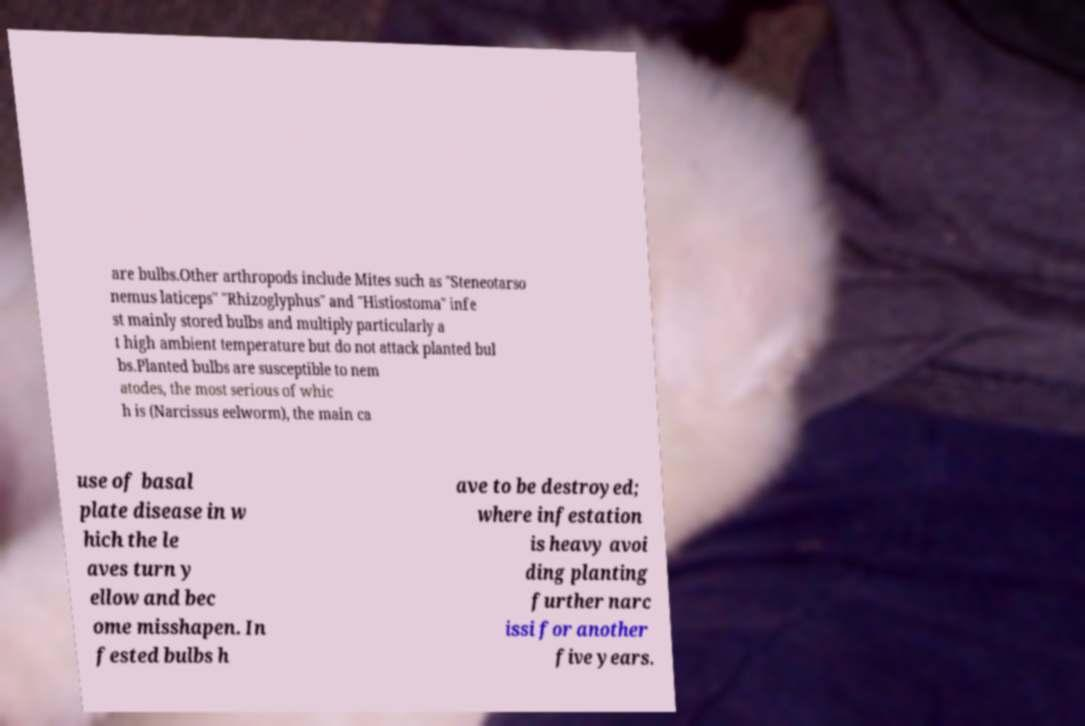Can you read and provide the text displayed in the image?This photo seems to have some interesting text. Can you extract and type it out for me? are bulbs.Other arthropods include Mites such as "Steneotarso nemus laticeps" "Rhizoglyphus" and "Histiostoma" infe st mainly stored bulbs and multiply particularly a t high ambient temperature but do not attack planted bul bs.Planted bulbs are susceptible to nem atodes, the most serious of whic h is (Narcissus eelworm), the main ca use of basal plate disease in w hich the le aves turn y ellow and bec ome misshapen. In fested bulbs h ave to be destroyed; where infestation is heavy avoi ding planting further narc issi for another five years. 